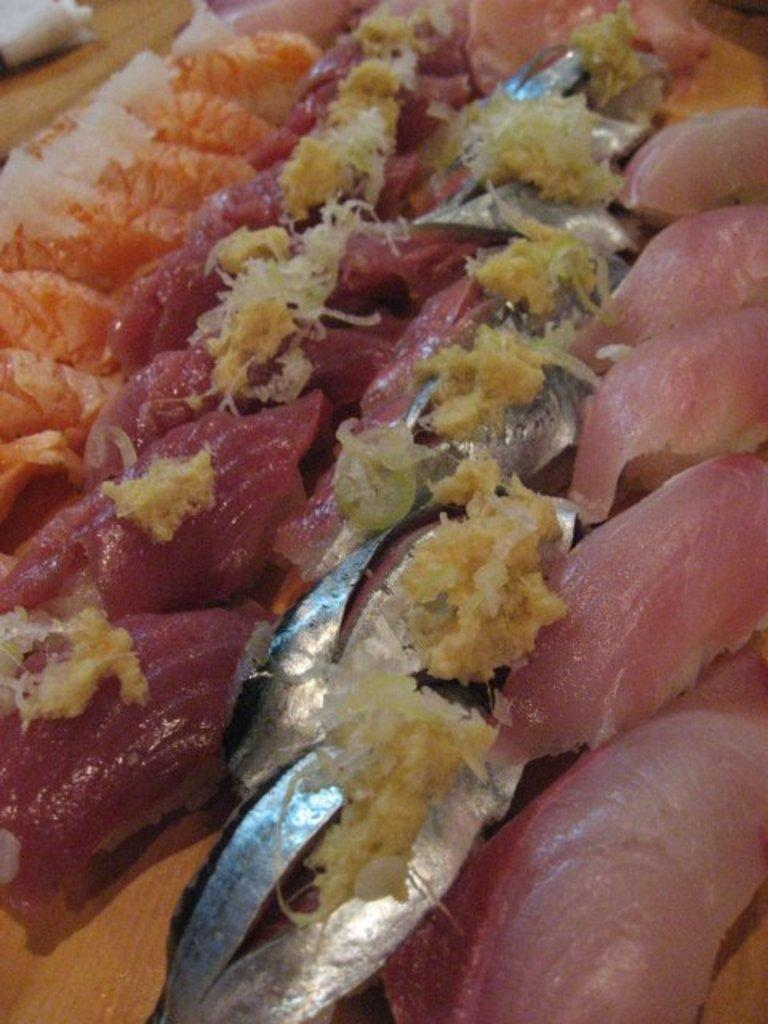What type of items can be seen in the image? The image contains food. What type of nail is being used to hang the title in the image? There is no nail or title present in the image; it only contains food. 